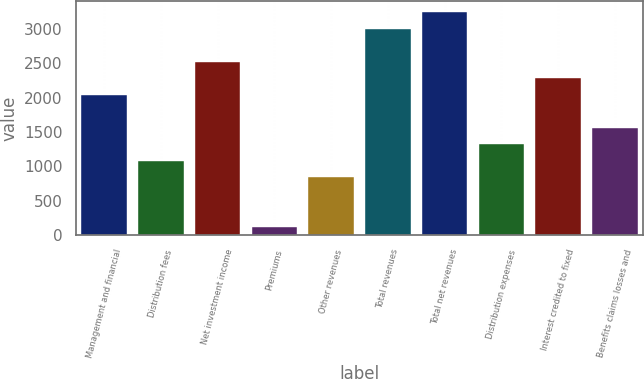Convert chart to OTSL. <chart><loc_0><loc_0><loc_500><loc_500><bar_chart><fcel>Management and financial<fcel>Distribution fees<fcel>Net investment income<fcel>Premiums<fcel>Other revenues<fcel>Total revenues<fcel>Total net revenues<fcel>Distribution expenses<fcel>Interest credited to fixed<fcel>Benefits claims losses and<nl><fcel>2042.8<fcel>1080.4<fcel>2524<fcel>118<fcel>839.8<fcel>3005.2<fcel>3245.8<fcel>1321<fcel>2283.4<fcel>1561.6<nl></chart> 